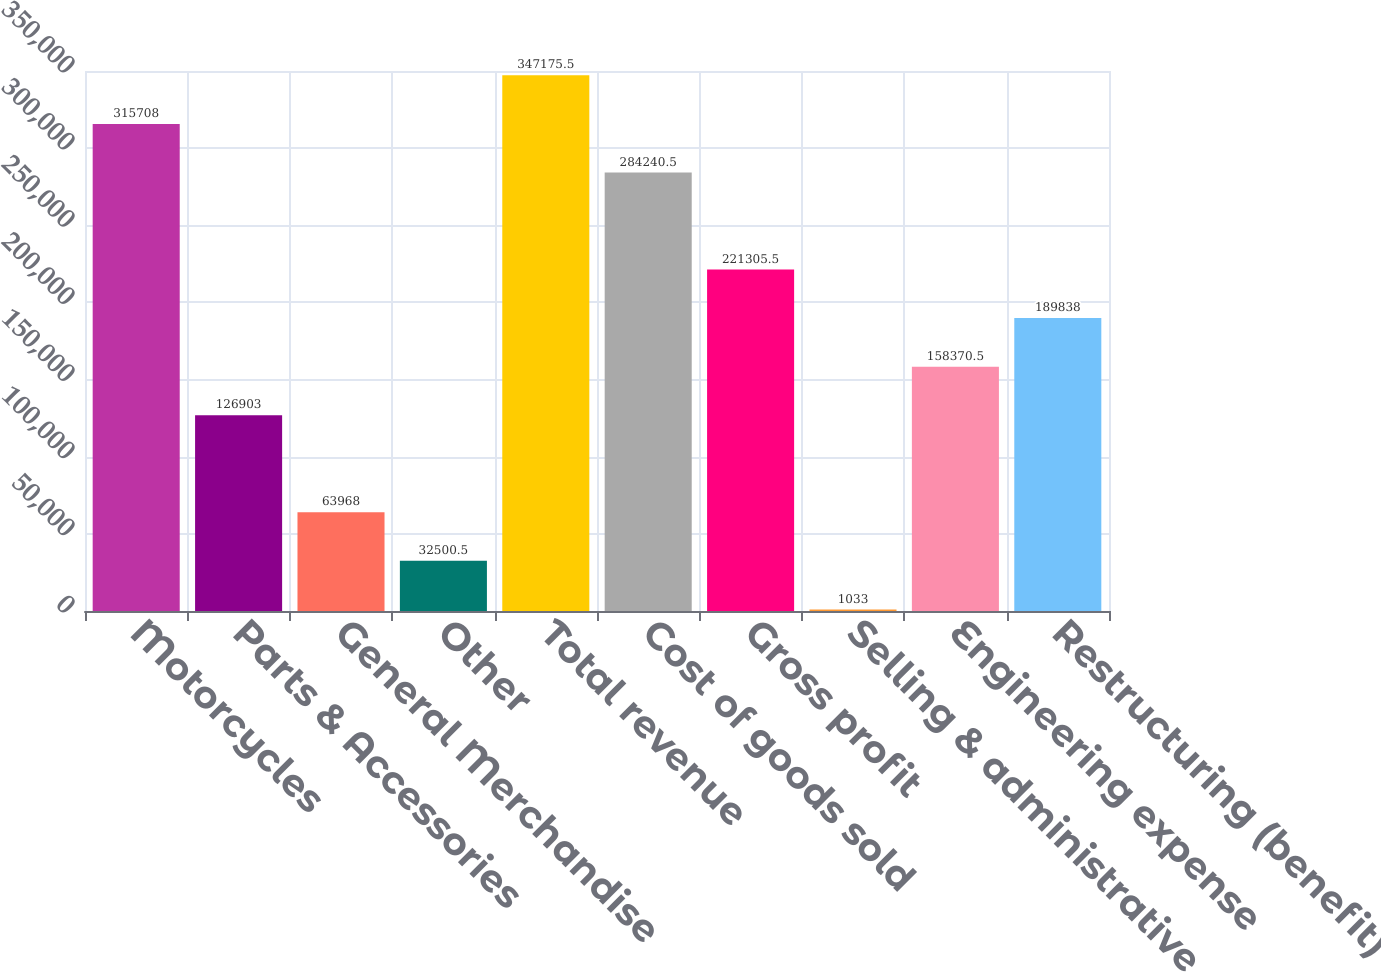<chart> <loc_0><loc_0><loc_500><loc_500><bar_chart><fcel>Motorcycles<fcel>Parts & Accessories<fcel>General Merchandise<fcel>Other<fcel>Total revenue<fcel>Cost of goods sold<fcel>Gross profit<fcel>Selling & administrative<fcel>Engineering expense<fcel>Restructuring (benefit)<nl><fcel>315708<fcel>126903<fcel>63968<fcel>32500.5<fcel>347176<fcel>284240<fcel>221306<fcel>1033<fcel>158370<fcel>189838<nl></chart> 